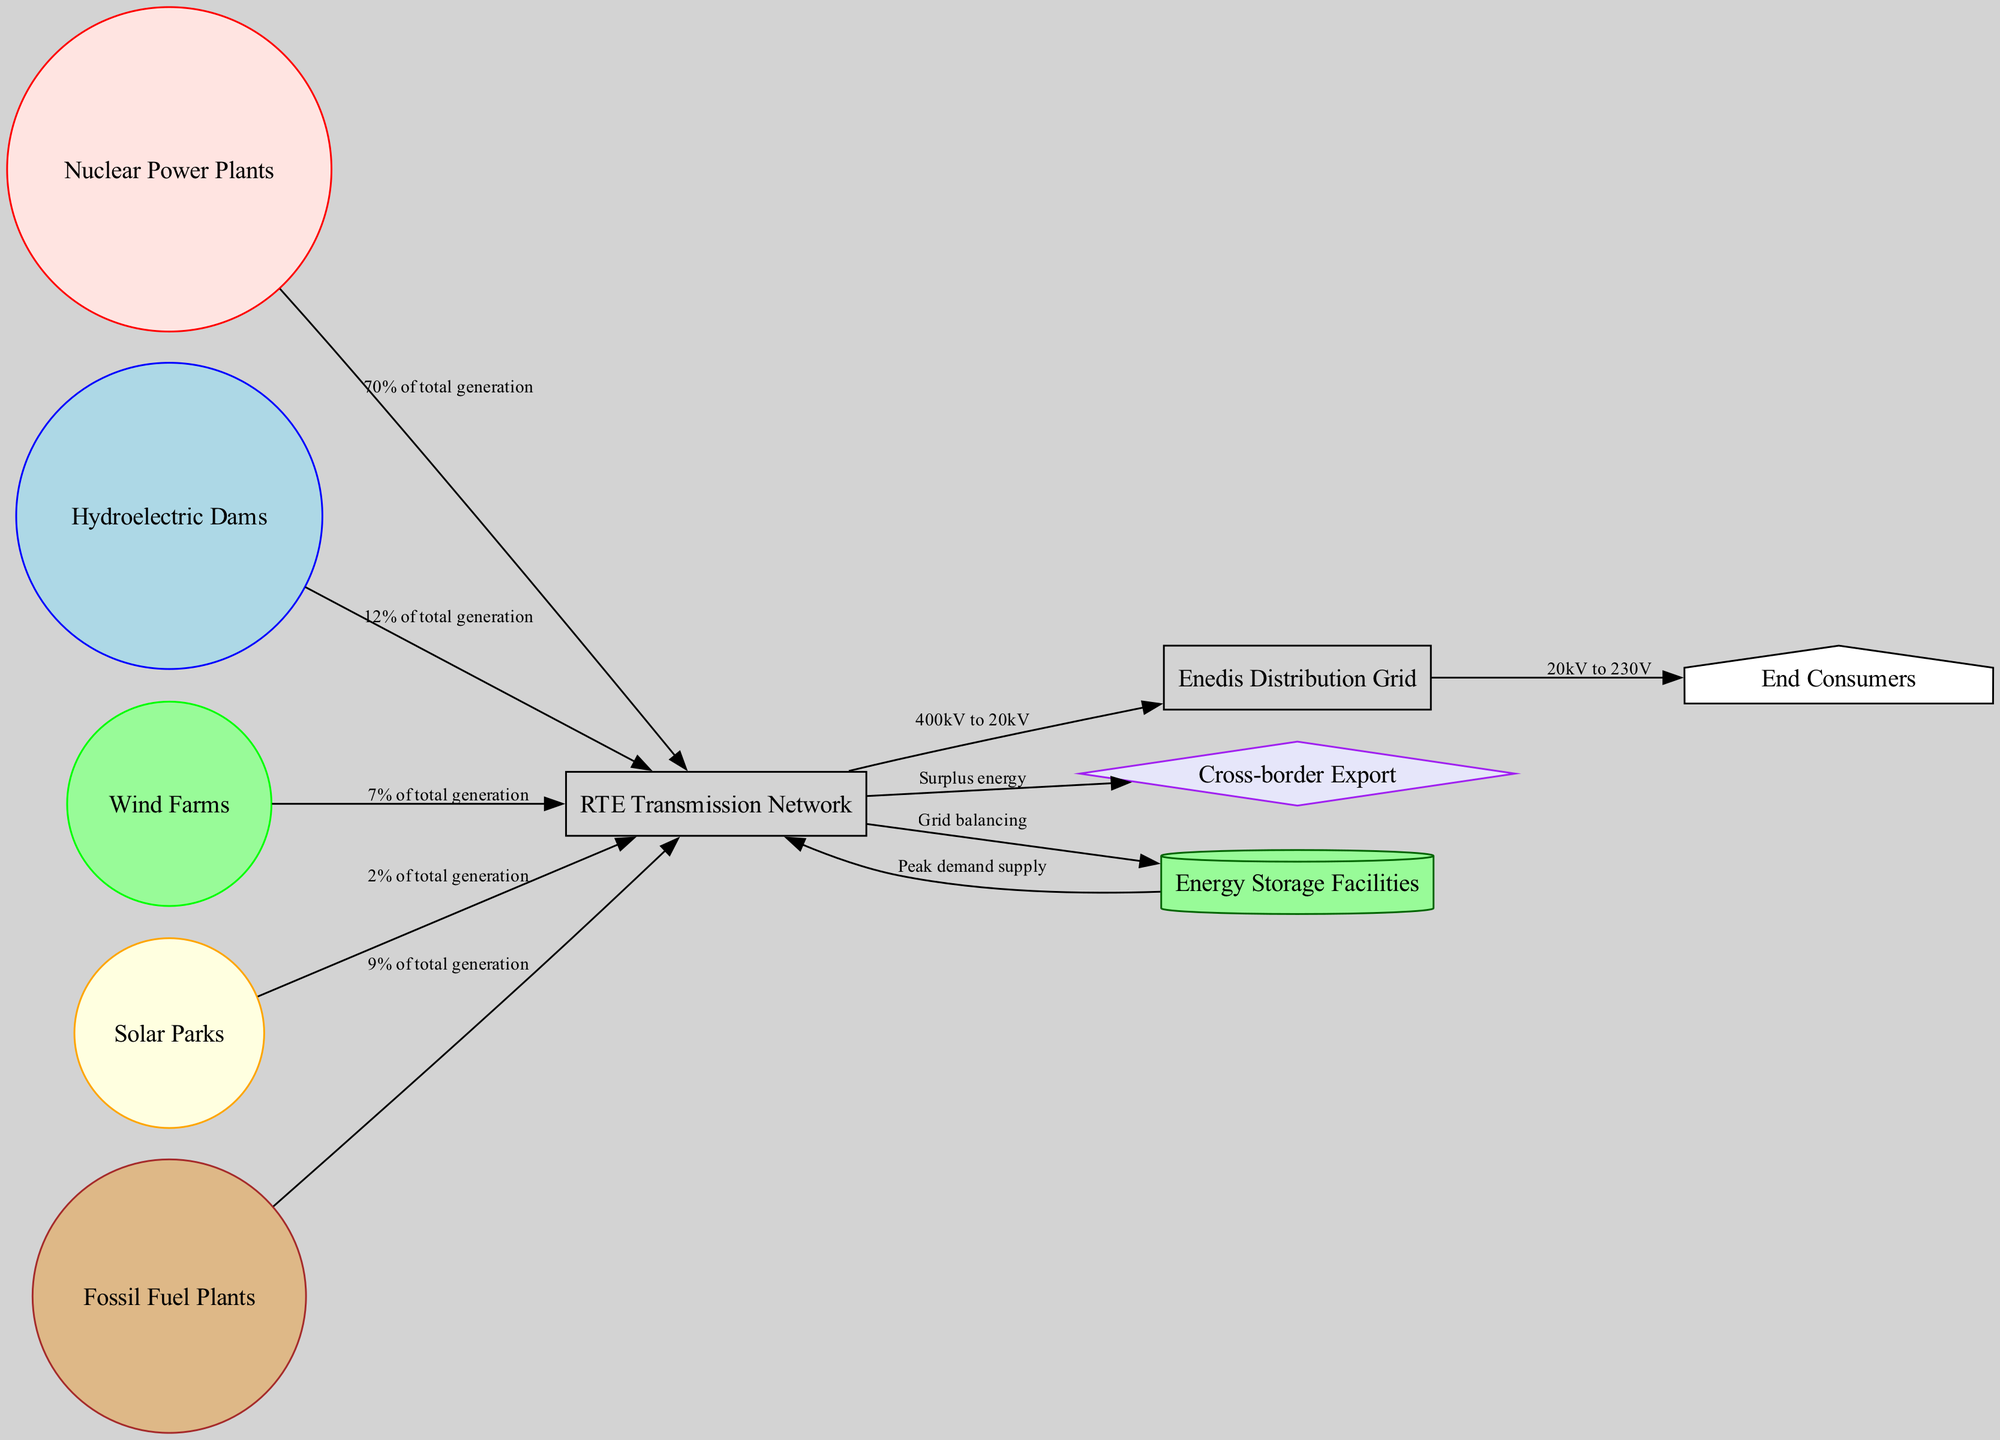What percentage of total generation is attributed to Nuclear Power Plants? The diagram specifies that Nuclear Power Plants contribute 70% of total generation, indicated in the edge from "nuclear" to "transmission".
Answer: 70% How many different energy sources are represented in the diagram? The diagram has a total of five distinct energy sources: Nuclear Power Plants, Hydroelectric Dams, Wind Farms, Solar Parks, and Fossil Fuel Plants. These nodes can be counted directly from the diagram.
Answer: 5 Which node delivers energy to End Consumers? The distribution grid is the intermediary node that connects to End Consumers as shown by the edge from "distribution" to "consumers".
Answer: Enedis Distribution Grid What is the role of Energy Storage Facilities in the energy flow diagram? Energy Storage Facilities receive energy from the transmission network for grid balancing and supply energy during peak demand, as indicated by the edges going to and from "storage".
Answer: Grid balancing and Peak demand supply What total generation percentage do renewable sources collectively represent? The renewable sources (Hydroelectric Dams, Wind Farms, and Solar Parks) contribute 12%, 7%, and 2% respectively, which totals to 21%. This is computed by adding their individual contributions together.
Answer: 21% What connection exists between the Transmission Network and Cross-border Export? The edge from the "transmission" node to the "export" node indicates that surplus energy is exported cross-border.
Answer: Surplus energy How does power travel from the Transmission Network to the Distribution Grid? The power flows from the Transmission Network to the Distribution Grid through a direct connection articulated by the edge labeled "400kV to 20kV". This shows the transformation and nurturing of energy from high to low voltage.
Answer: 400kV to 20kV What energy source has the lowest contribution to total generation? Among all the energy sources depicted in the diagram, Solar Parks, which contribute 2% to total generation, have the lowest proportion.
Answer: Solar Parks How do fossil fuel plants contribute to the overall energy generation? The diagram indicates that Fossil Fuel Plants account for 9% of total generation, as shown by the edge linking "fossil" to "transmission".
Answer: 9% 